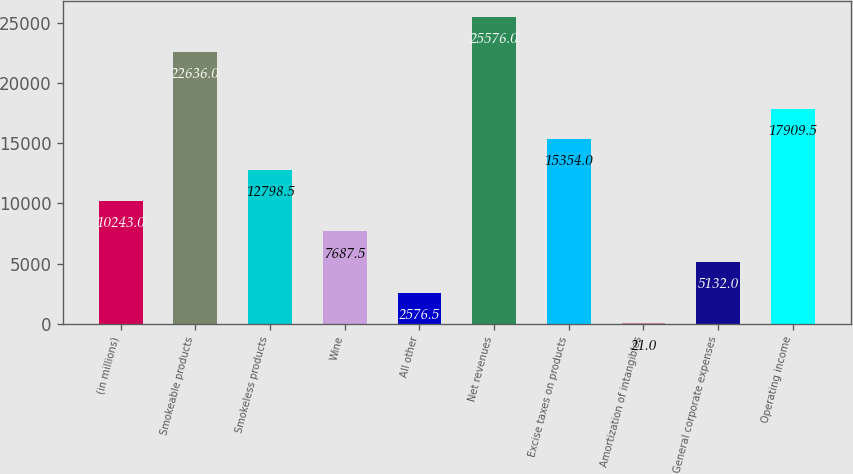<chart> <loc_0><loc_0><loc_500><loc_500><bar_chart><fcel>(in millions)<fcel>Smokeable products<fcel>Smokeless products<fcel>Wine<fcel>All other<fcel>Net revenues<fcel>Excise taxes on products<fcel>Amortization of intangibles<fcel>General corporate expenses<fcel>Operating income<nl><fcel>10243<fcel>22636<fcel>12798.5<fcel>7687.5<fcel>2576.5<fcel>25576<fcel>15354<fcel>21<fcel>5132<fcel>17909.5<nl></chart> 